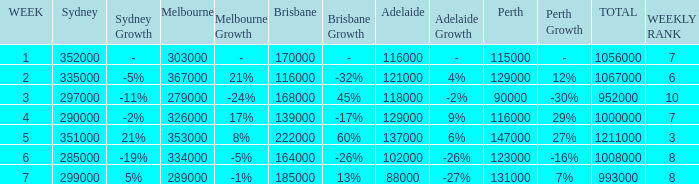How many Adelaide viewers were there in Week 5? 137000.0. 